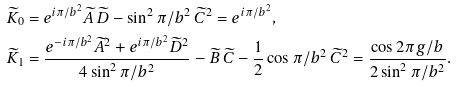Convert formula to latex. <formula><loc_0><loc_0><loc_500><loc_500>& \widetilde { K } _ { 0 } = e ^ { i \pi / b ^ { 2 } } \widetilde { A } \, \widetilde { D } - \sin ^ { 2 } \pi / b ^ { 2 } \, \widetilde { C } ^ { 2 } = e ^ { i \pi / b ^ { 2 } } , \\ & \widetilde { K } _ { 1 } = \frac { e ^ { - i \pi / b ^ { 2 } } \widetilde { A } ^ { 2 } + e ^ { i \pi / b ^ { 2 } } \widetilde { D } ^ { 2 } } { 4 \sin ^ { 2 } \pi / b ^ { 2 } } - \widetilde { B } \, \widetilde { C } - \frac { 1 } { 2 } \cos \pi / b ^ { 2 } \, \widetilde { C } ^ { 2 } = \frac { \cos 2 \pi g / b } { 2 \sin ^ { 2 } \pi / b ^ { 2 } } .</formula> 